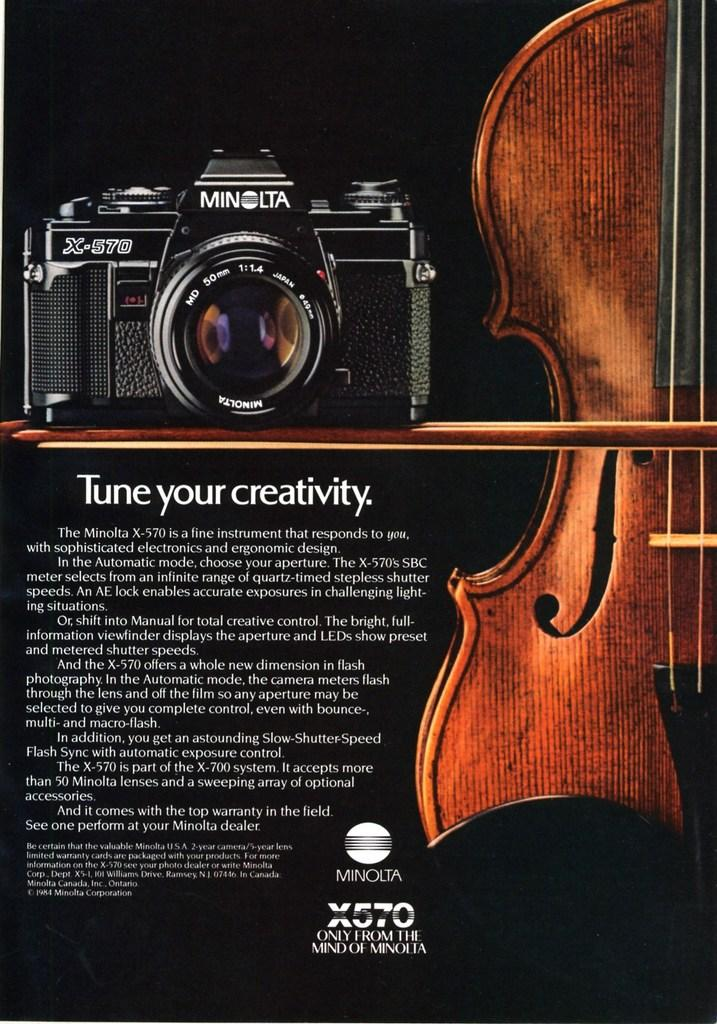What is the main object in the image? There is a camera in the image. Where is the camera located? The camera is on the top left side. What other object can be seen in the image? There is a guitar in the image. Where is the guitar located? The guitar is on the right side. How many breaths can be heard coming from the guitar in the image? There are no breaths associated with the guitar in the image, as it is an inanimate object. 